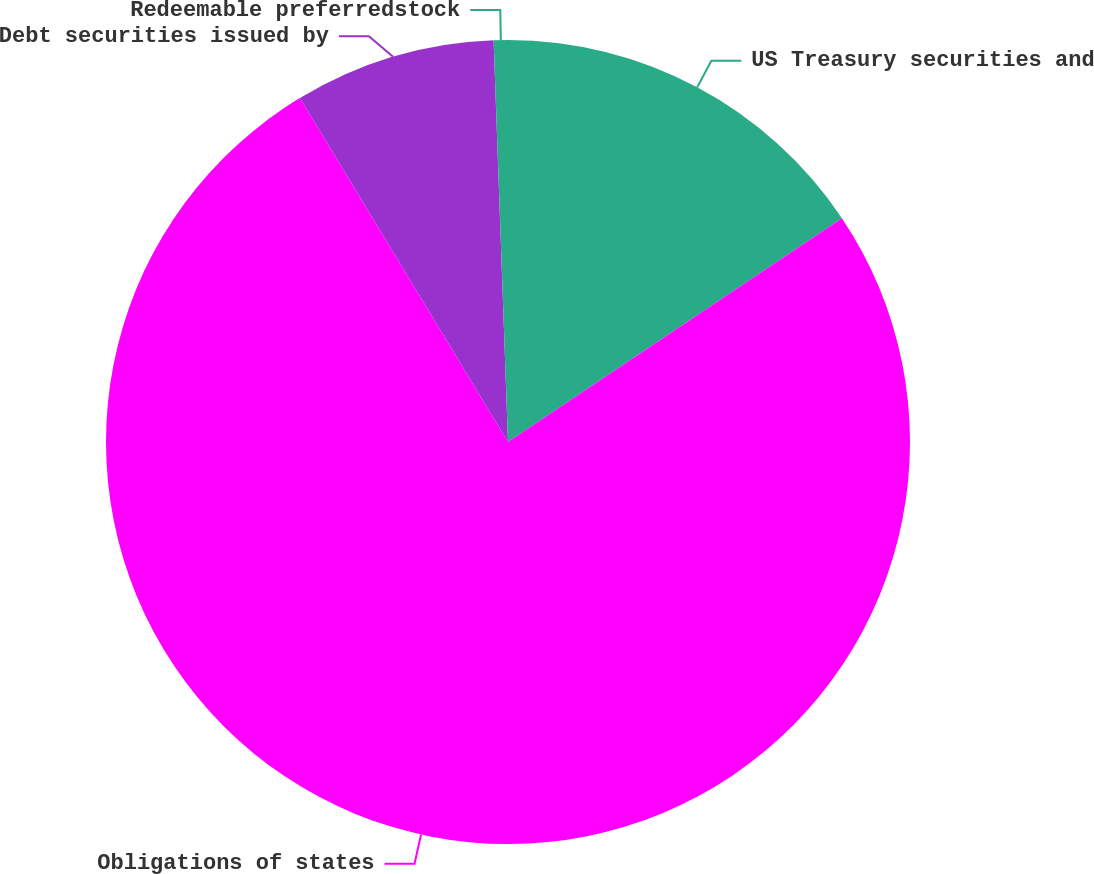Convert chart to OTSL. <chart><loc_0><loc_0><loc_500><loc_500><pie_chart><fcel>US Treasury securities and<fcel>Obligations of states<fcel>Debt securities issued by<fcel>Redeemable preferredstock<nl><fcel>15.6%<fcel>75.74%<fcel>8.09%<fcel>0.57%<nl></chart> 